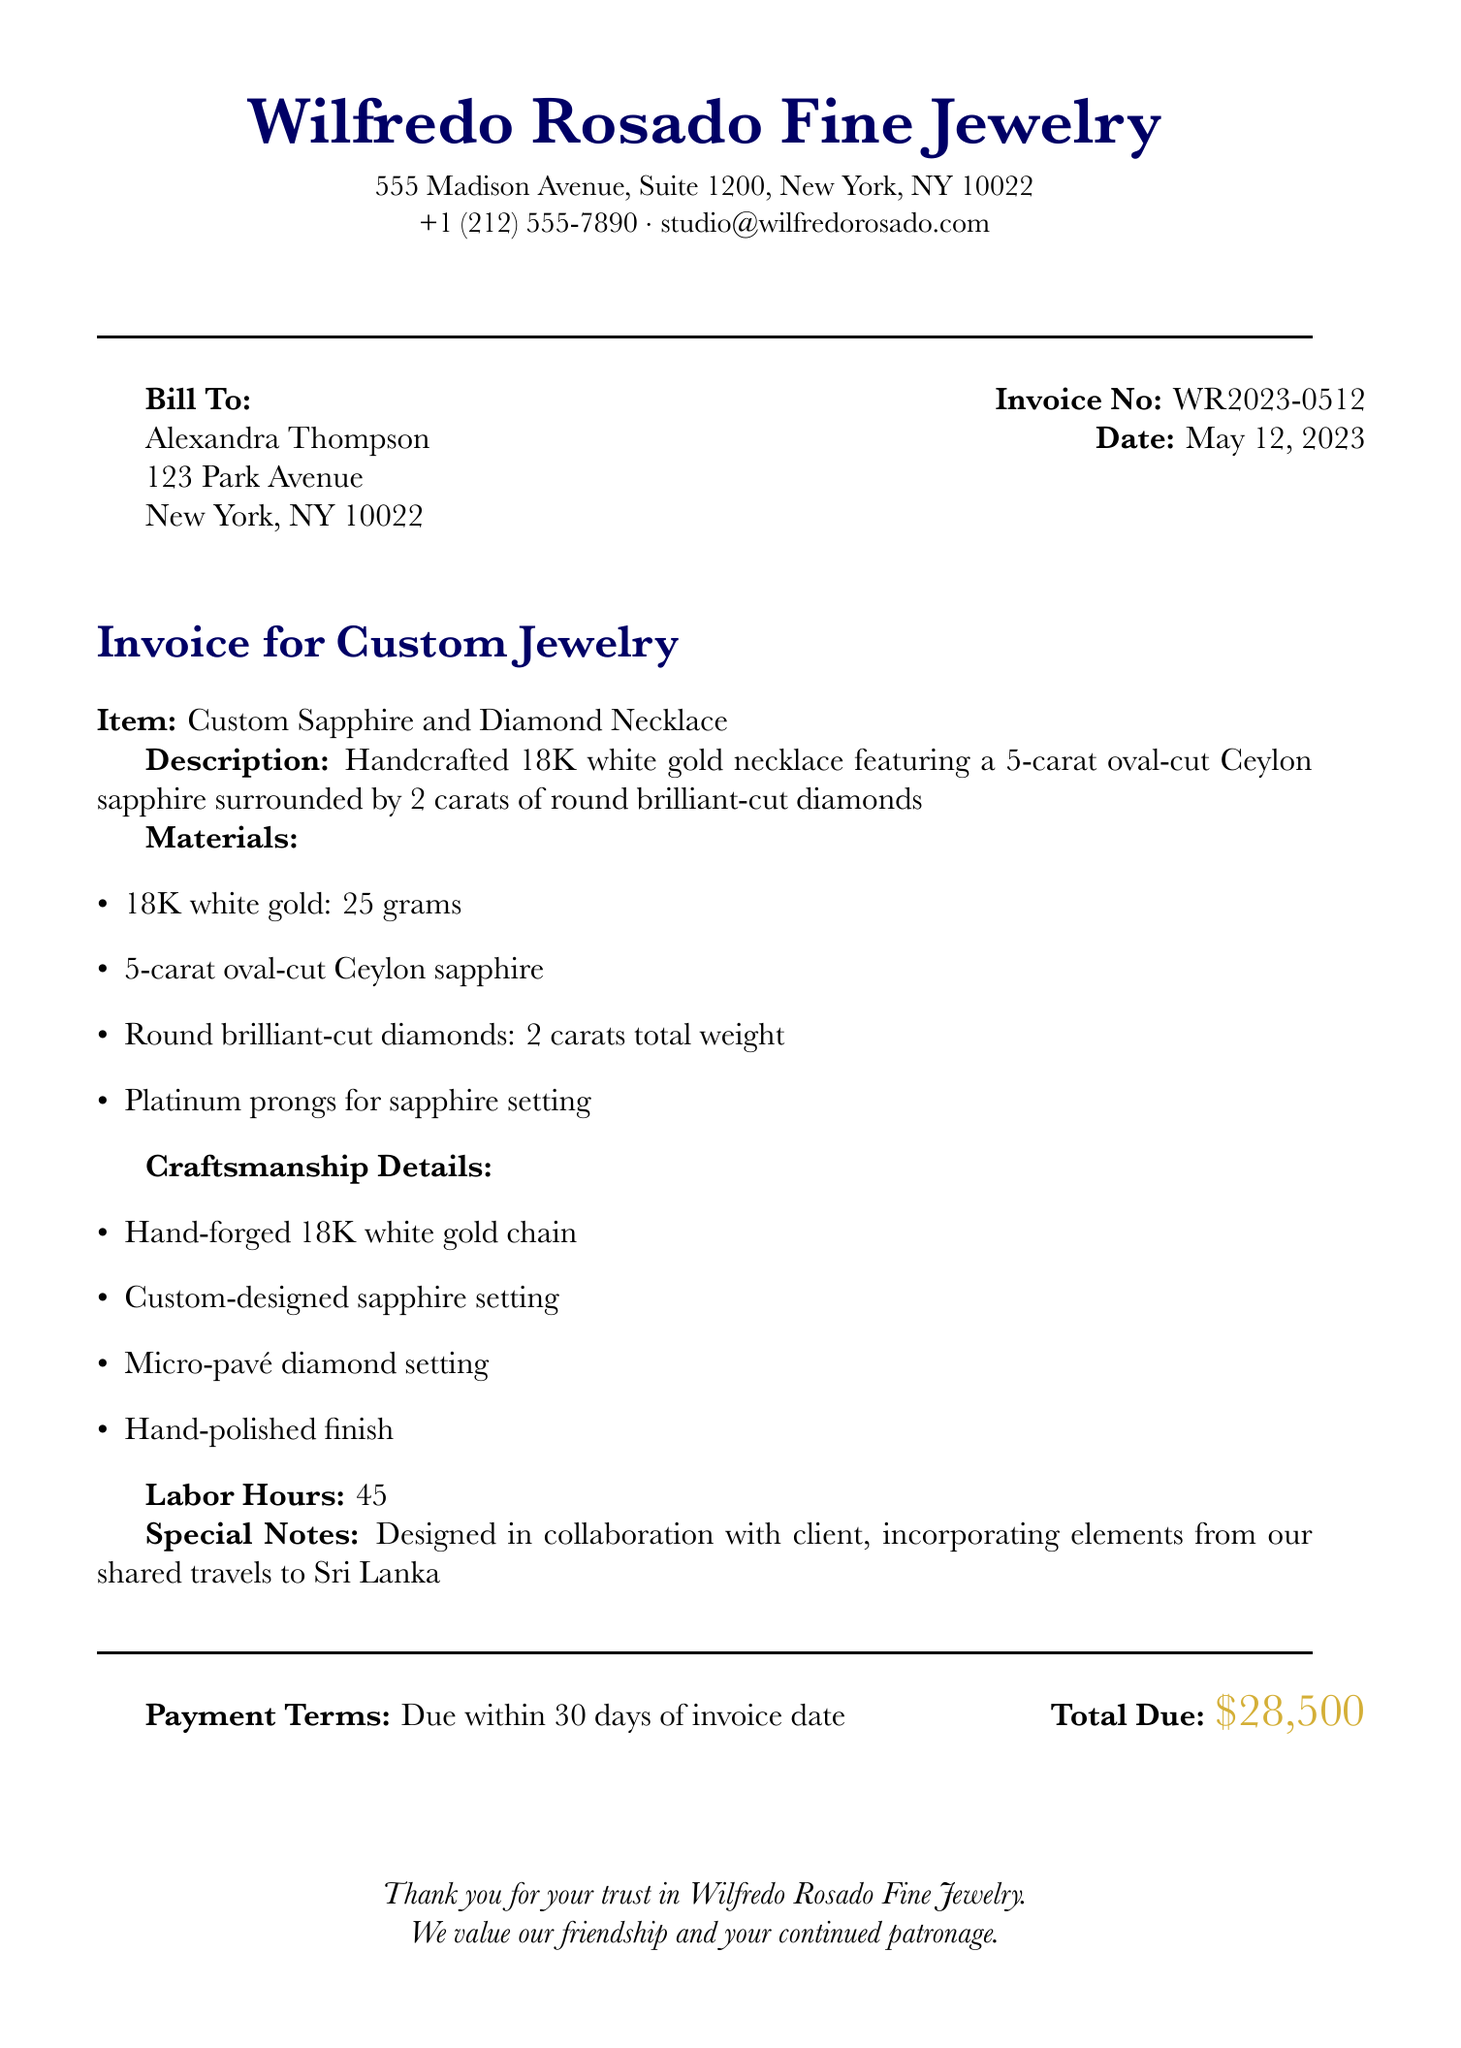What is the total due? The total due is specified at the bottom of the invoice.
Answer: $28,500 Who is the bill to? The invoice specifies to whom it is billed.
Answer: Alexandra Thompson What date was the invoice issued? The date is mentioned clearly on the invoice.
Answer: May 12, 2023 What materials are used in the necklace? The materials used are listed in an itemized format.
Answer: 18K white gold, Ceylon sapphire, diamonds, platinum prongs How many labor hours were spent on the necklace? The labor hours are indicated in the invoice details.
Answer: 45 What type of diamonds are featured in the necklace? The type of diamonds is described in the item details.
Answer: Round brilliant-cut diamonds What is the payment term? The payment terms are stated in the invoice.
Answer: Due within 30 days of invoice date What special note is included in the invoice? A special note about the design collaboration is highlighted in the document.
Answer: Designed in collaboration with client, incorporating elements from our shared travels to Sri Lanka 